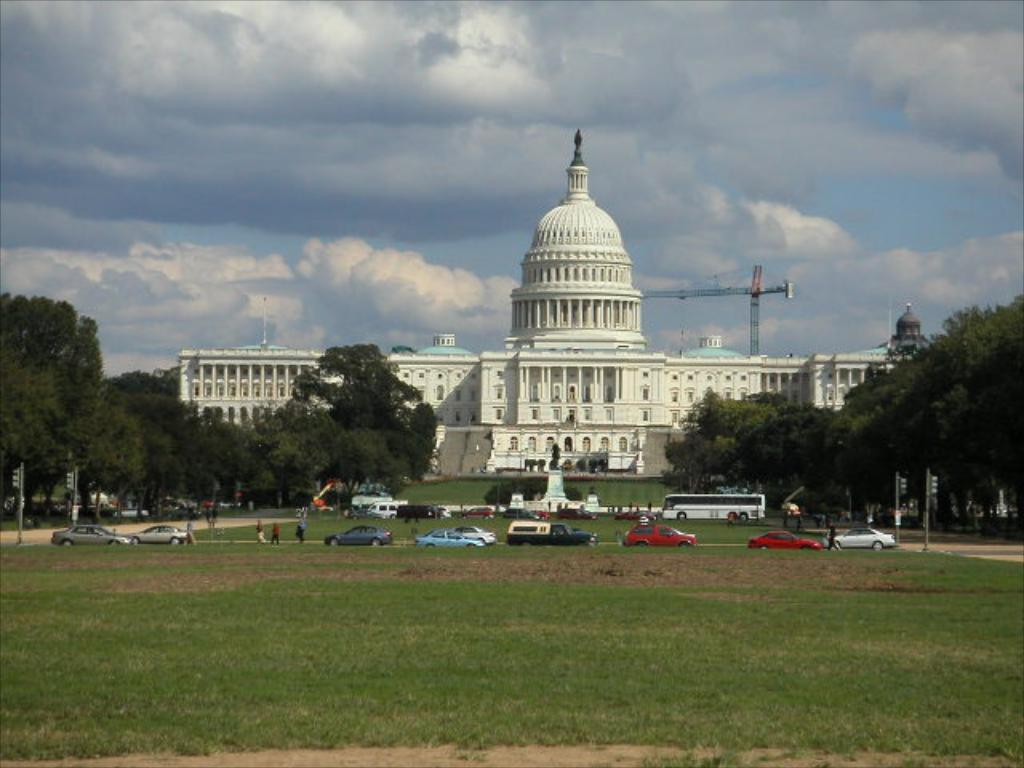What can be seen on the road in the image? There are cars on the road in the image. What type of natural environment is visible on either side of the road? There is grassland on either side of the road, and trees are present on either side of the grassland. What type of structure can be seen in the background of the image? There is a palace in the background of the image. What part of the natural environment is visible in the image? The sky is visible in the image, and clouds are present in the sky. Can you tell me how many pipes are visible in the image? There are no pipes present in the image. What type of airport can be seen in the background of the image? There is no airport present in the image; it features a palace in the background. 